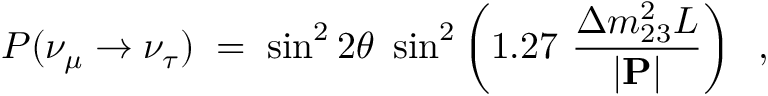<formula> <loc_0><loc_0><loc_500><loc_500>P ( \nu _ { \mu } \rightarrow \nu _ { \tau } ) \, = \, \sin ^ { 2 } 2 \theta \sin ^ { 2 } \left ( 1 . 2 7 \frac { \Delta m _ { 2 3 } ^ { 2 } L } { | { P } | } \right ) \, ,</formula> 